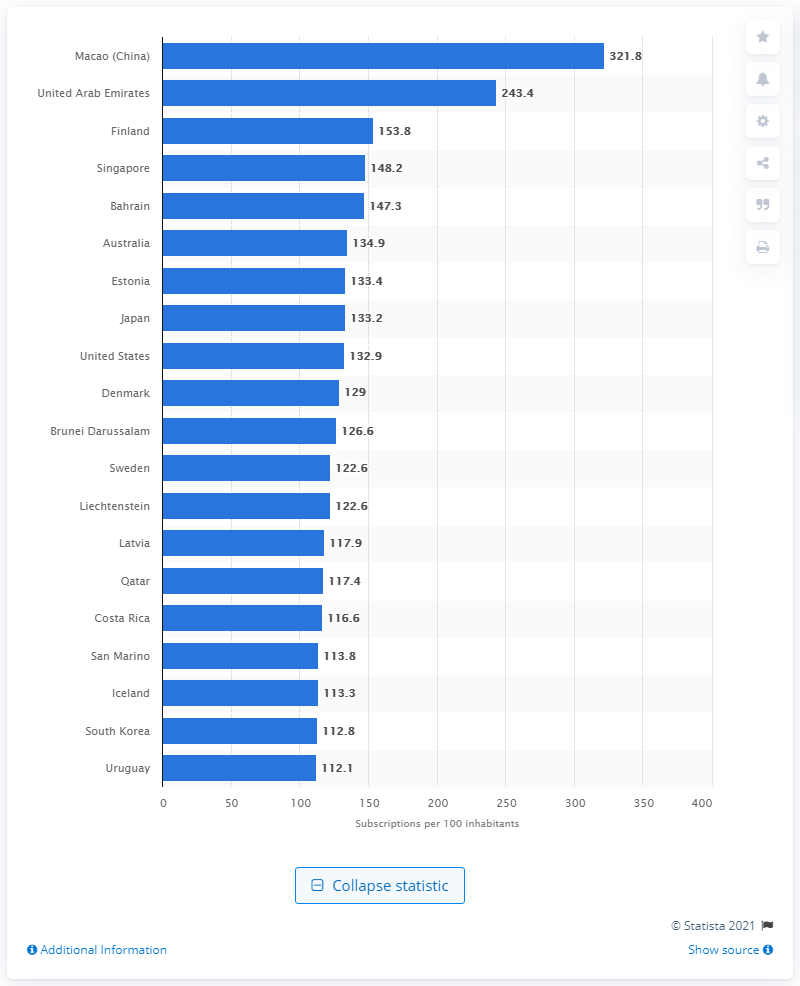Indicate a few pertinent items in this graphic. In 2017, there were 148,200 mobile broadband subscriptions in Singapore. In 2017, Macao had 321.8 mobile broadband subscriptions per 100 inhabitants. 